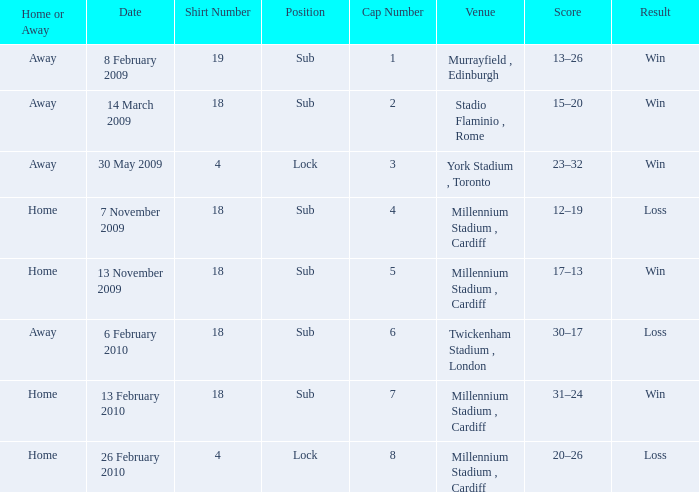Give me the full table as a dictionary. {'header': ['Home or Away', 'Date', 'Shirt Number', 'Position', 'Cap Number', 'Venue', 'Score', 'Result'], 'rows': [['Away', '8 February 2009', '19', 'Sub', '1', 'Murrayfield , Edinburgh', '13–26', 'Win'], ['Away', '14 March 2009', '18', 'Sub', '2', 'Stadio Flaminio , Rome', '15–20', 'Win'], ['Away', '30 May 2009', '4', 'Lock', '3', 'York Stadium , Toronto', '23–32', 'Win'], ['Home', '7 November 2009', '18', 'Sub', '4', 'Millennium Stadium , Cardiff', '12–19', 'Loss'], ['Home', '13 November 2009', '18', 'Sub', '5', 'Millennium Stadium , Cardiff', '17–13', 'Win'], ['Away', '6 February 2010', '18', 'Sub', '6', 'Twickenham Stadium , London', '30–17', 'Loss'], ['Home', '13 February 2010', '18', 'Sub', '7', 'Millennium Stadium , Cardiff', '31–24', 'Win'], ['Home', '26 February 2010', '4', 'Lock', '8', 'Millennium Stadium , Cardiff', '20–26', 'Loss']]} Can you tell me the lowest Cap Number that has the Date of 8 february 2009, and the Shirt Number larger than 19? None. 